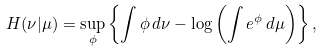<formula> <loc_0><loc_0><loc_500><loc_500>H ( \nu | \mu ) = \sup _ { \phi } \left \{ \int \phi \, d \nu - \log \left ( \int e ^ { \phi } \, d \mu \right ) \right \} ,</formula> 